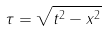<formula> <loc_0><loc_0><loc_500><loc_500>\tau = \sqrt { t ^ { 2 } - x ^ { 2 } }</formula> 